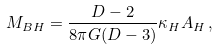<formula> <loc_0><loc_0><loc_500><loc_500>M _ { B H } = \frac { D - 2 } { 8 \pi G ( D - 3 ) } \kappa _ { H } A _ { H } \, ,</formula> 